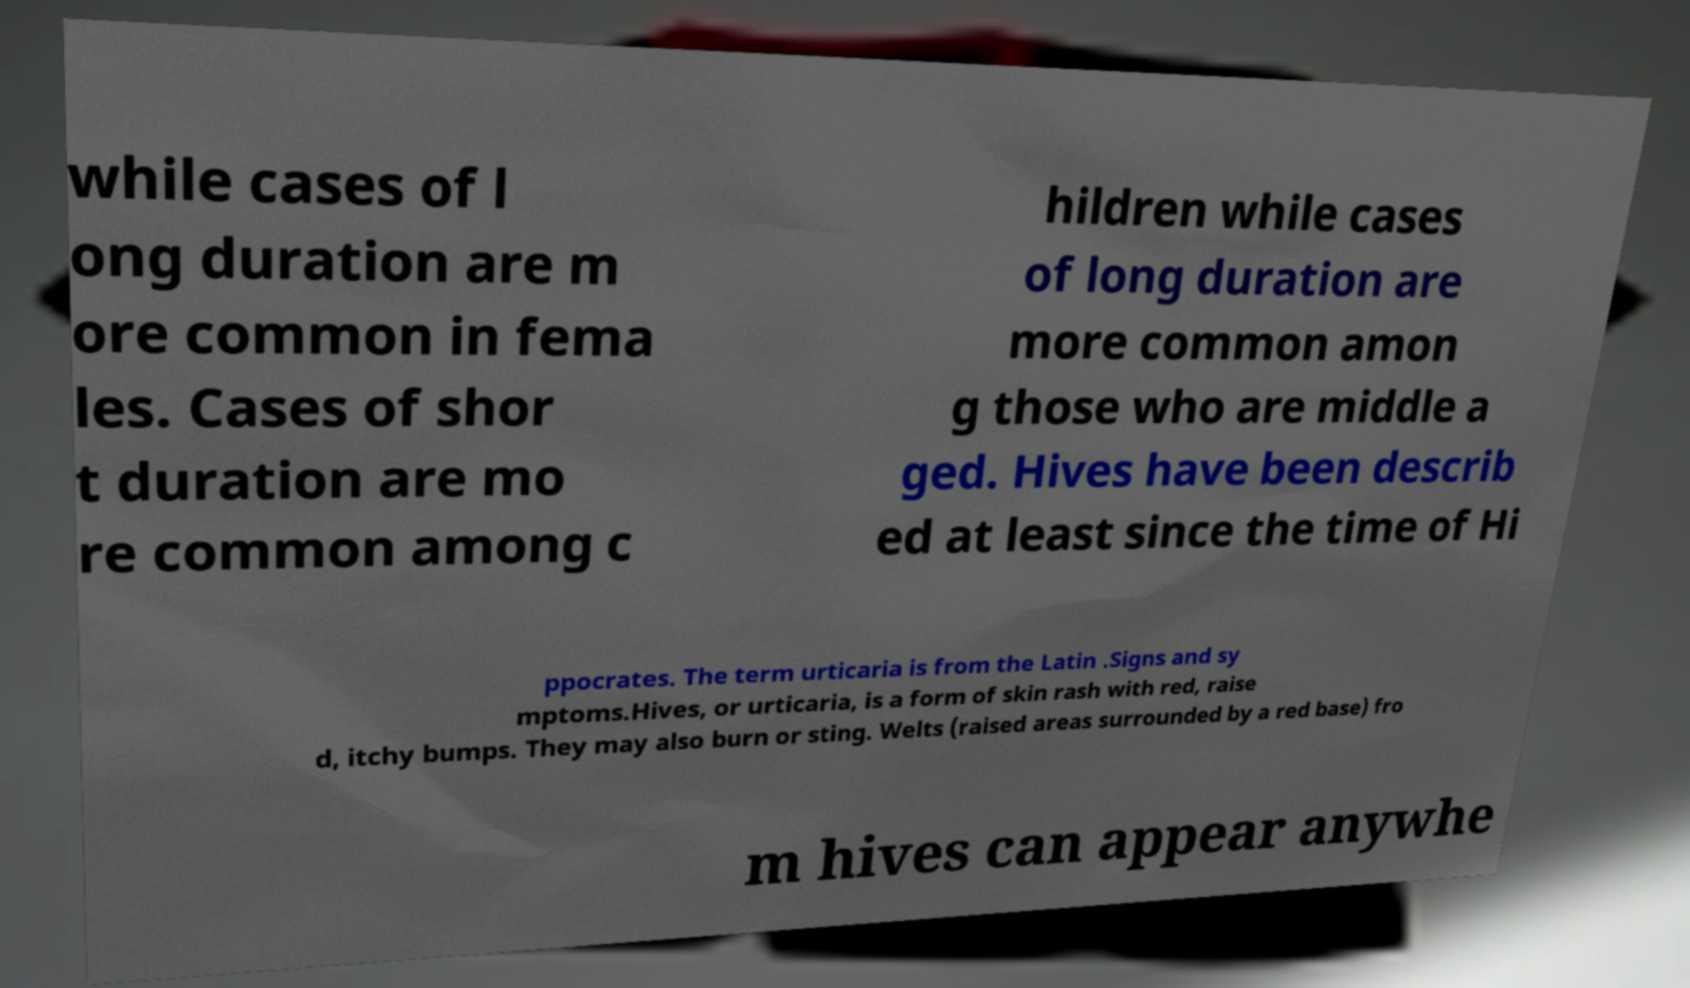There's text embedded in this image that I need extracted. Can you transcribe it verbatim? while cases of l ong duration are m ore common in fema les. Cases of shor t duration are mo re common among c hildren while cases of long duration are more common amon g those who are middle a ged. Hives have been describ ed at least since the time of Hi ppocrates. The term urticaria is from the Latin .Signs and sy mptoms.Hives, or urticaria, is a form of skin rash with red, raise d, itchy bumps. They may also burn or sting. Welts (raised areas surrounded by a red base) fro m hives can appear anywhe 